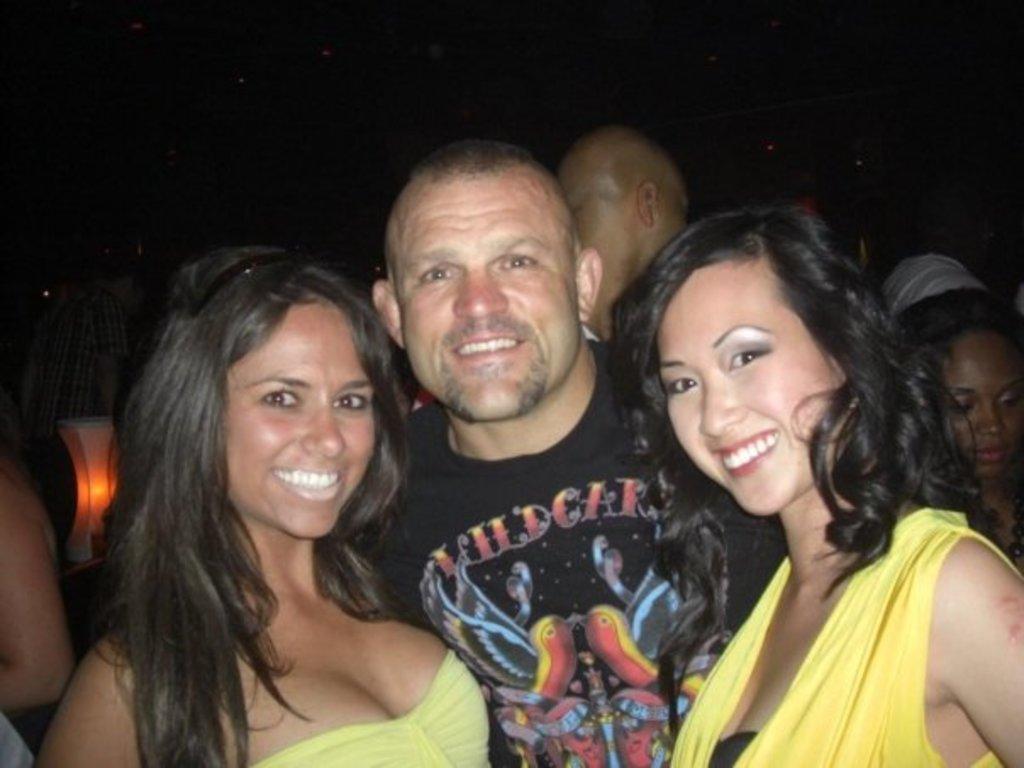Could you give a brief overview of what you see in this image? In this picture I can see three persons smiling, there is an object, there are group of people standing, and there is dark background. 